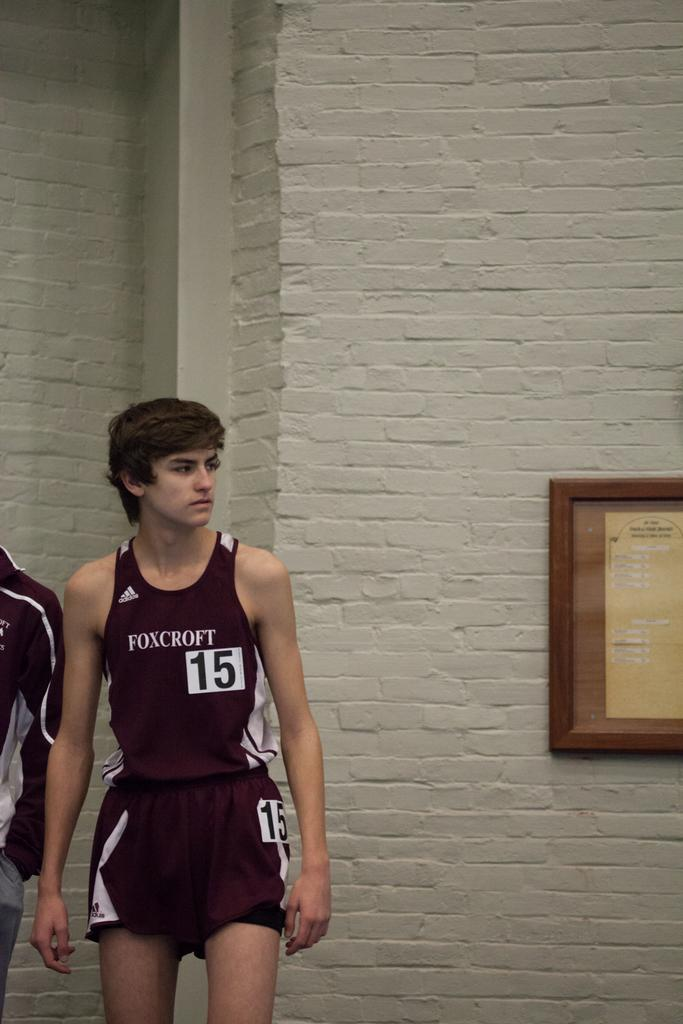<image>
Render a clear and concise summary of the photo. A boy with a maroon Foxcroft jersey on . 